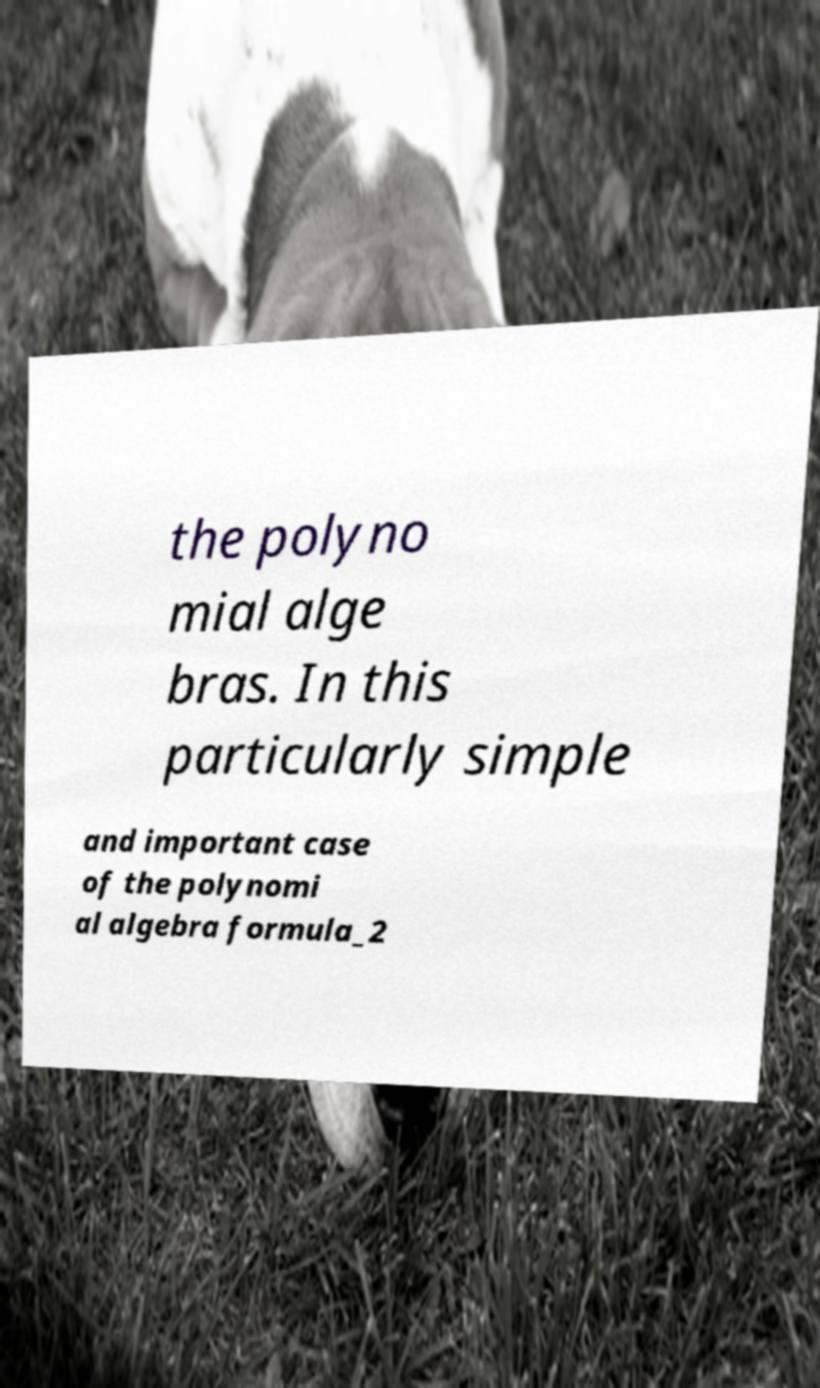There's text embedded in this image that I need extracted. Can you transcribe it verbatim? the polyno mial alge bras. In this particularly simple and important case of the polynomi al algebra formula_2 